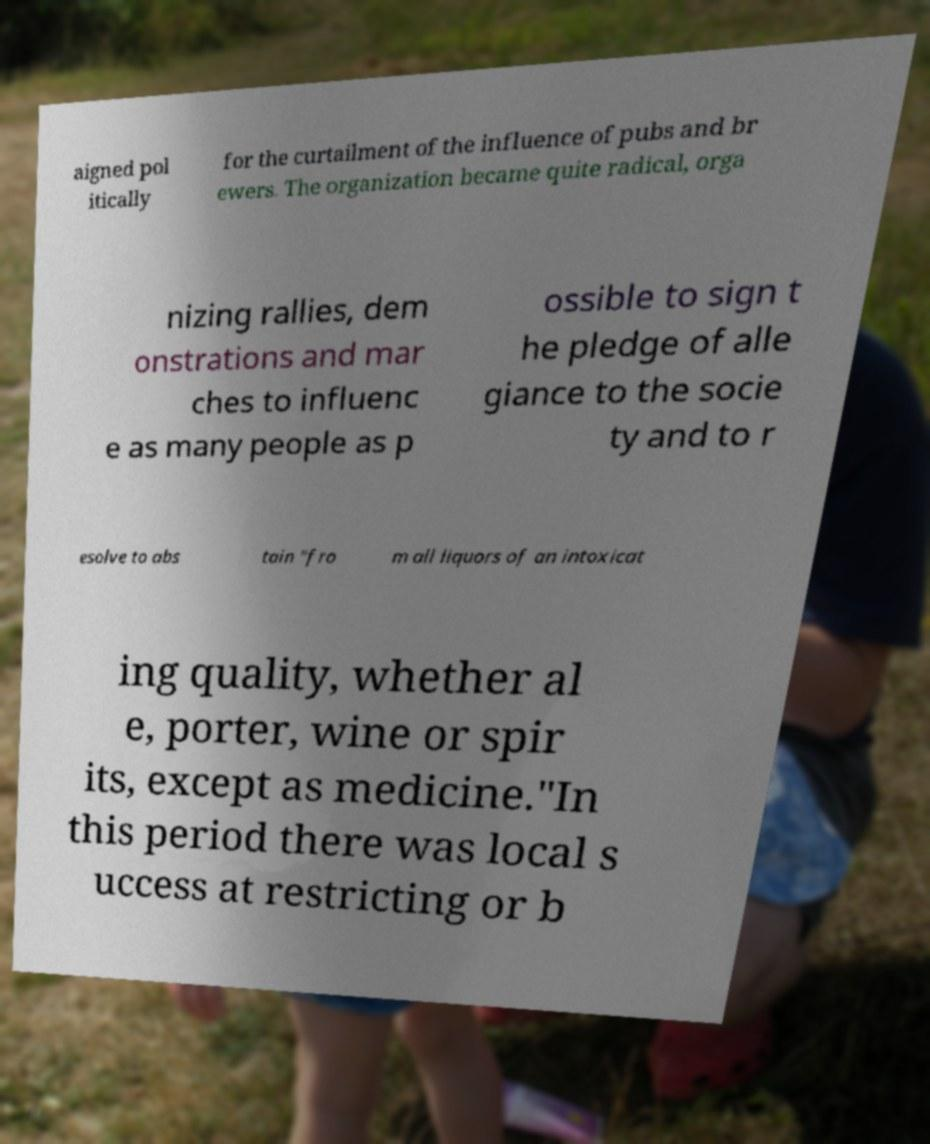Can you accurately transcribe the text from the provided image for me? aigned pol itically for the curtailment of the influence of pubs and br ewers. The organization became quite radical, orga nizing rallies, dem onstrations and mar ches to influenc e as many people as p ossible to sign t he pledge of alle giance to the socie ty and to r esolve to abs tain "fro m all liquors of an intoxicat ing quality, whether al e, porter, wine or spir its, except as medicine."In this period there was local s uccess at restricting or b 